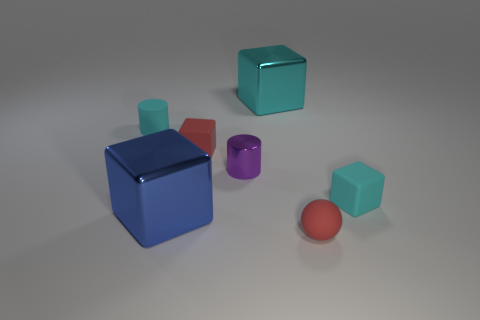Subtract all cyan cubes. How many were subtracted if there are1cyan cubes left? 1 Subtract all tiny red matte blocks. How many blocks are left? 3 Subtract 0 purple spheres. How many objects are left? 7 Subtract all cylinders. How many objects are left? 5 Subtract 1 blocks. How many blocks are left? 3 Subtract all brown blocks. Subtract all red cylinders. How many blocks are left? 4 Subtract all brown blocks. How many purple cylinders are left? 1 Subtract all red cubes. Subtract all large brown objects. How many objects are left? 6 Add 5 large cyan metallic objects. How many large cyan metallic objects are left? 6 Add 3 matte spheres. How many matte spheres exist? 4 